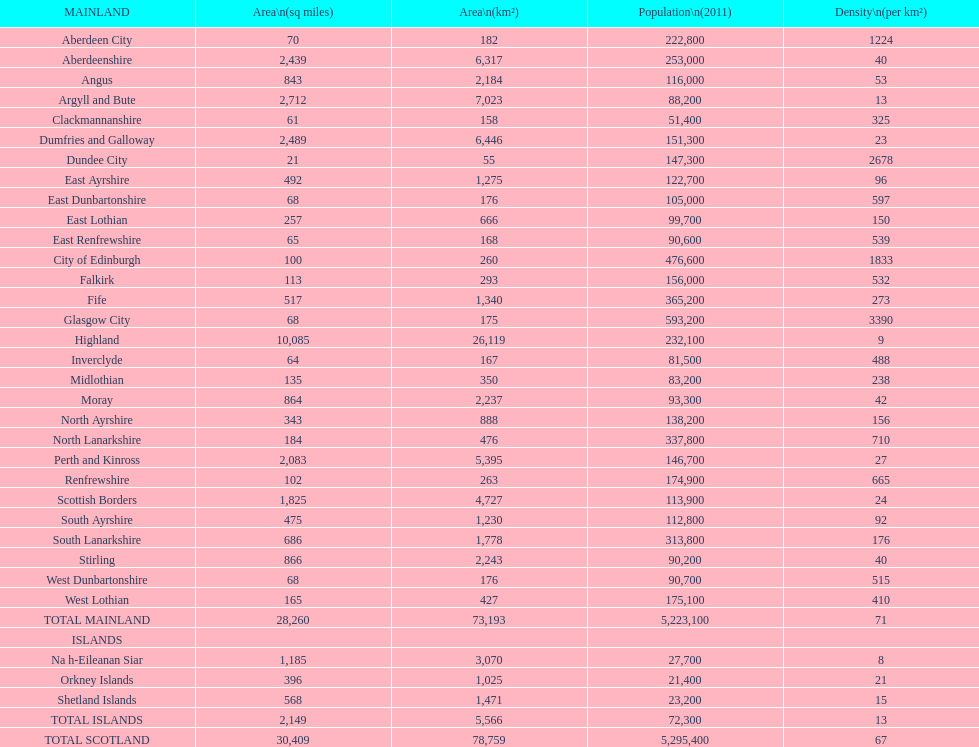What is the difference in square miles from angus and fife? 326. 